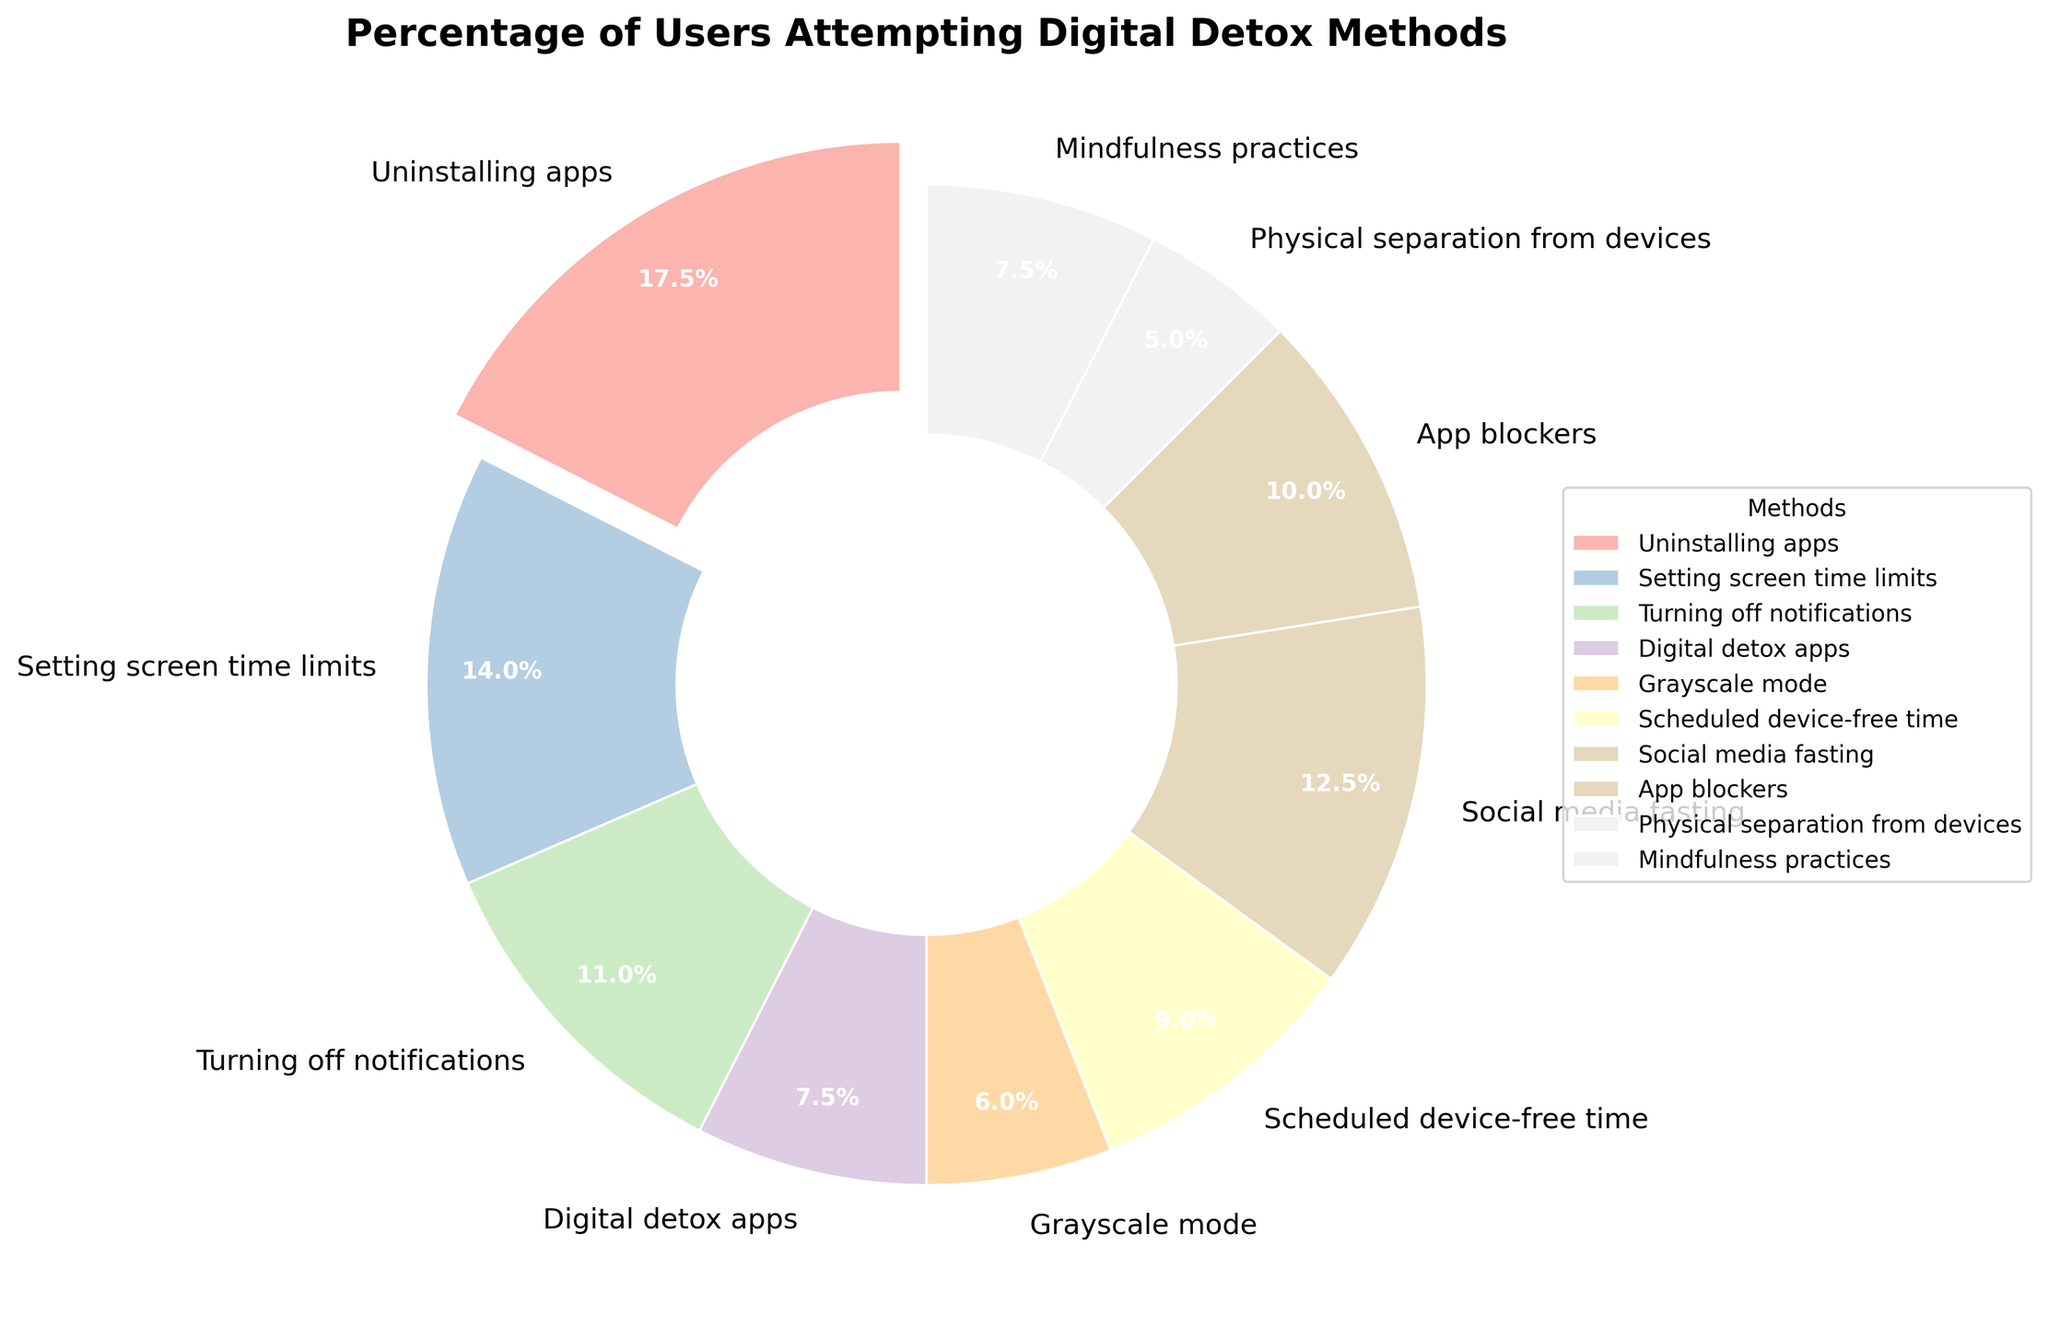what is the proportion of users using Uninstalling apps compared to those using Digital detox apps? Uninstalling apps have 35% and Digital detox apps have 15%. The proportion can be calculated as 35% / 15% = 2.33, so users trying Uninstalling apps are roughly 2.33 times more than those using Digital detox apps.
Answer: 2.33 Which digital detox method is the least popular? By looking at the percentages, Physical separation from devices has the smallest percentage at 10%.
Answer: Physical separation from devices What is the combined percentage of users using methods involving app management (Uninstalling apps, Digital detox apps, App blockers)? Summing up the percentages of Uninstalling apps (35%), Digital detox apps (15%), and App blockers (20%) gives 35 + 15 + 20 = 70%.
Answer: 70% Are there more users using Social media fasting or Scheduled device-free time? By how much? Social media fasting is used by 25% of users and Scheduled device-free time by 18%. The difference is 25% - 18% = 7%.
Answer: Social media fasting by 7% What color represents the method Setting screen time limits? In the pie chart, Setting screen time limits appears as a distinct segment. The color used for Setting screen time limits is found in the legend. Assuming standard chart norms, this segment could be differentiated visually.
Answer: As seen in the legend (e.g., light blue, pink, etc., depending on the color palette used in the pie chart) Which method is highlighted or exploded in the pie chart? The method with the highest percentage is typically highlighted or exploded in a pie chart. Here, Uninstalling apps has the highest percentage of 35%.
Answer: Uninstalling apps Do more users prefer turning off notifications over using App blockers? Turning off notifications is used by 22% of users, whereas App blockers are used by 20%. Therefore, Turning off notifications is slightly more preferred.
Answer: Yes, by 2% What is the difference in percentage points between users using Mindfulness practices and those using Grayscale mode? Mindfulness practices have 15% and Grayscale mode has 12%, so the difference is 15% - 12% = 3 percentage points.
Answer: 3 calculate the combined percentage of the three least popular methods The three least popular methods are Physical separation from devices (10%), Grayscale mode (12%), and Digital detox apps (15%). Adding these gives 10 + 12 + 15 = 37%.
Answer: 37% What is the median percentage of all digital detox methods? To find the median, first list the percentages in ascending order: 10, 12, 15, 15, 18, 20, 22, 25, 28, 35. The median is the average of the 5th and 6th values: (18 + 20) / 2 = 19.
Answer: 19 